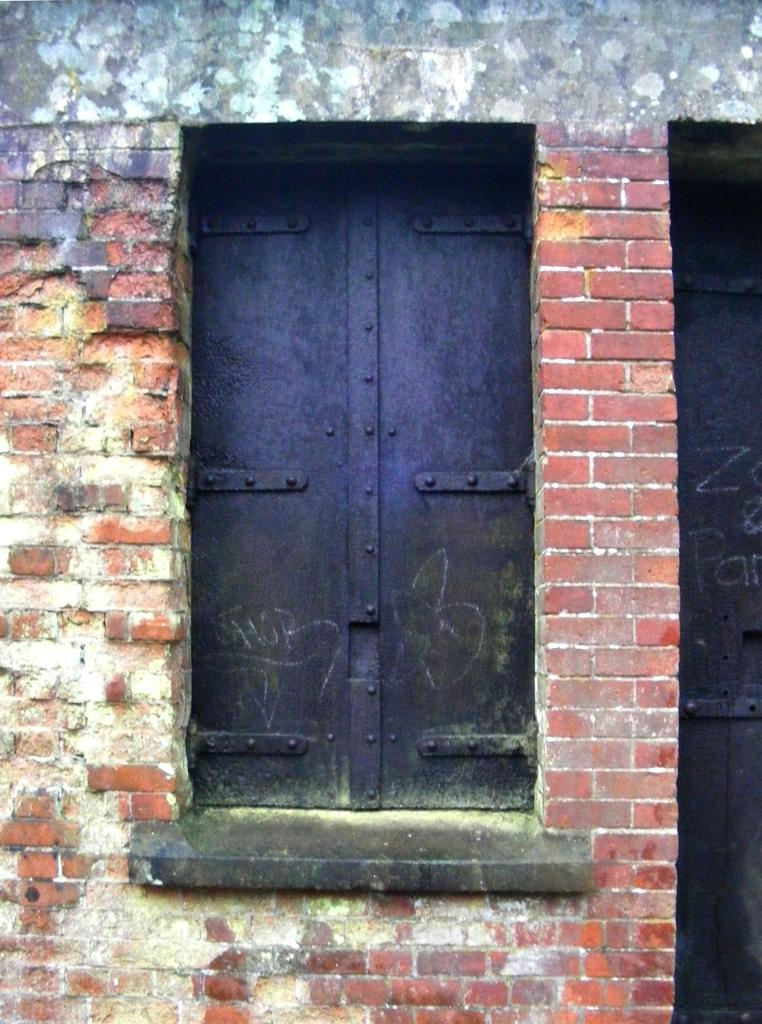What type of wall is present in the left corner of the image? There is a brick wall in the left corner of the image. What type of wall is present in the right corner of the image? There is a brick wall in the right corner of the image. What can be seen in the foreground of the image? There is a metal window in the foreground of the image. What is visible in the background of the image? There is a wall in the background of the image. What color is the orange in the image? There is no orange present in the image. What is the aftermath of the error in the image? There is no error or aftermath mentioned in the image. 